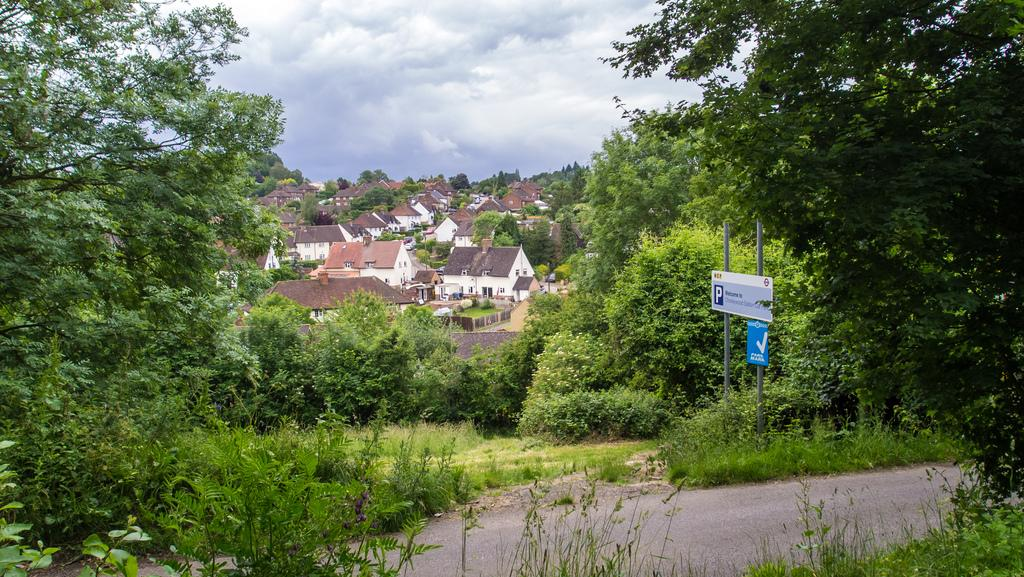What is the main feature of the image? There is a road in the image. What else can be seen in the image besides the road? There are boards, trees, buildings, and the sky visible in the image. Can you describe the background of the image? The background of the image includes trees, buildings, and the sky. What is the manager's income in the image? There is no manager or income mentioned in the image; it features a road, boards, trees, buildings, and the sky. 